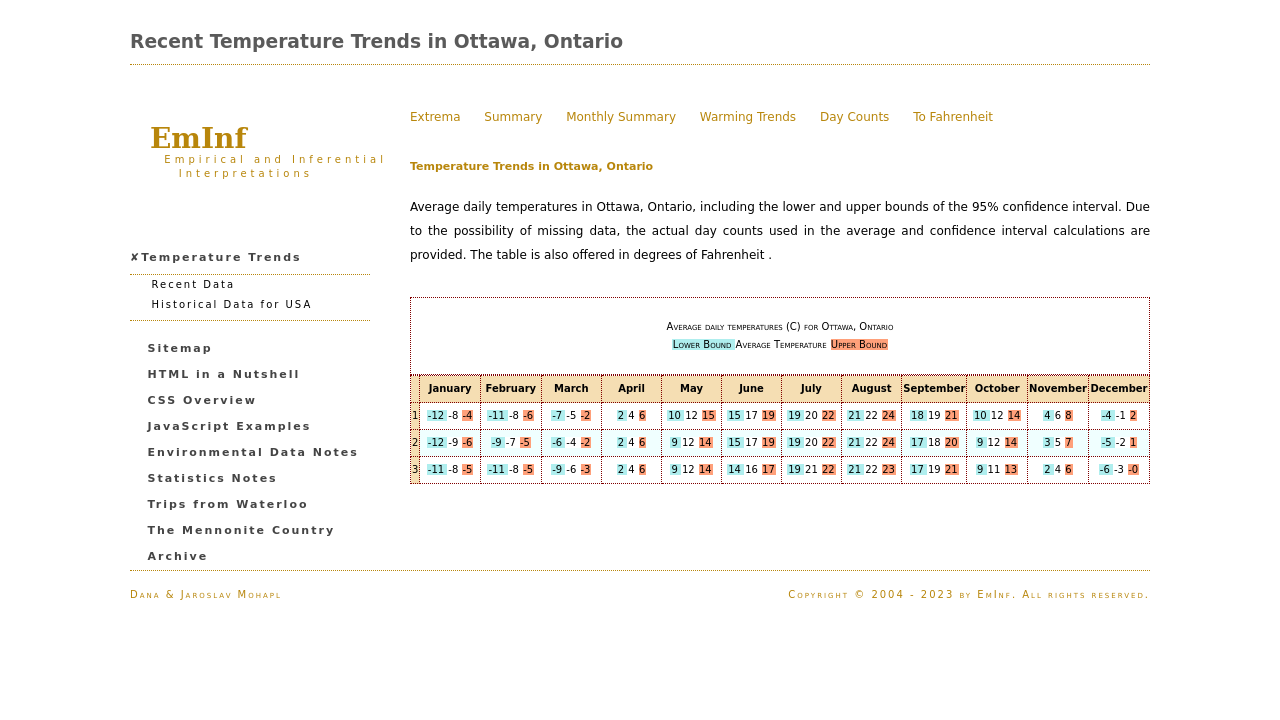What's the procedure for constructing this website from scratch with HTML? To construct the website from scratch as shown in the image, start by setting up the basic HTML structure including doctype, html, head, and body tags. Inside, you'll need a header for the title, sections for each of the menu items, and a table to display the temperature data. Use CSS for styling, such as background colors, text formatting, and alignments. Incorporate JavaScript for interactive elements like changing between Celsius and Fahrenheit. Lastly, ensure your site is responsive and accessible to all users. 